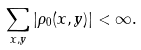<formula> <loc_0><loc_0><loc_500><loc_500>\sum _ { x , y } | \rho _ { 0 } ( x , y ) | < \infty .</formula> 